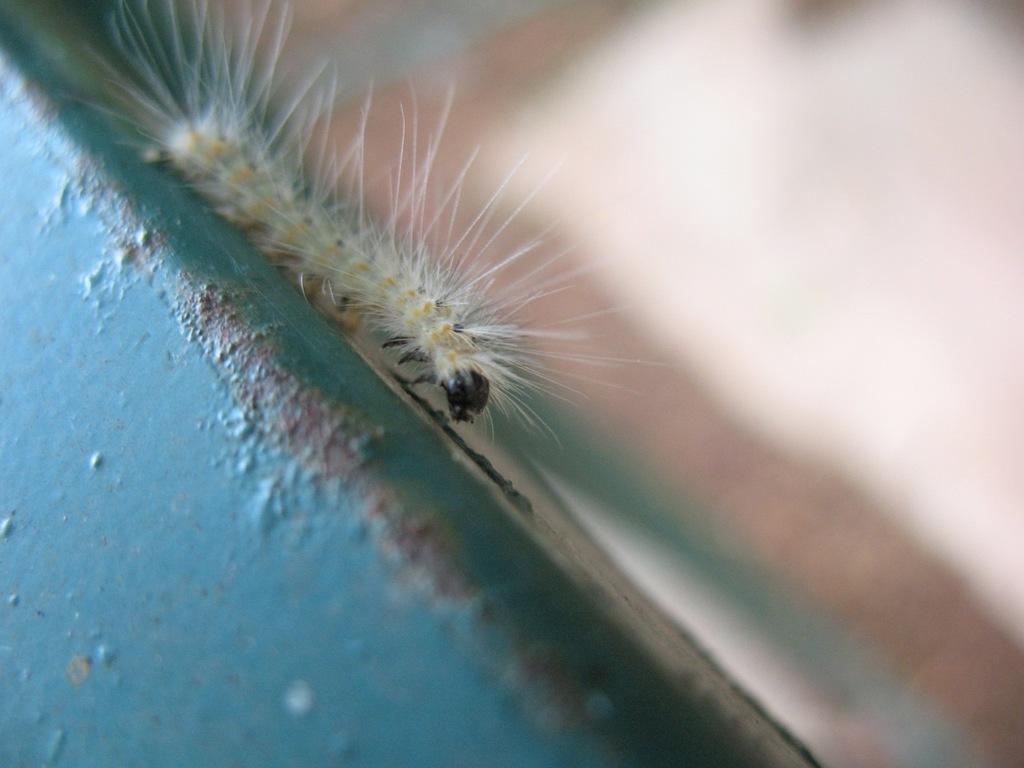Describe this image in one or two sentences. There is an insect on the blue wall. 